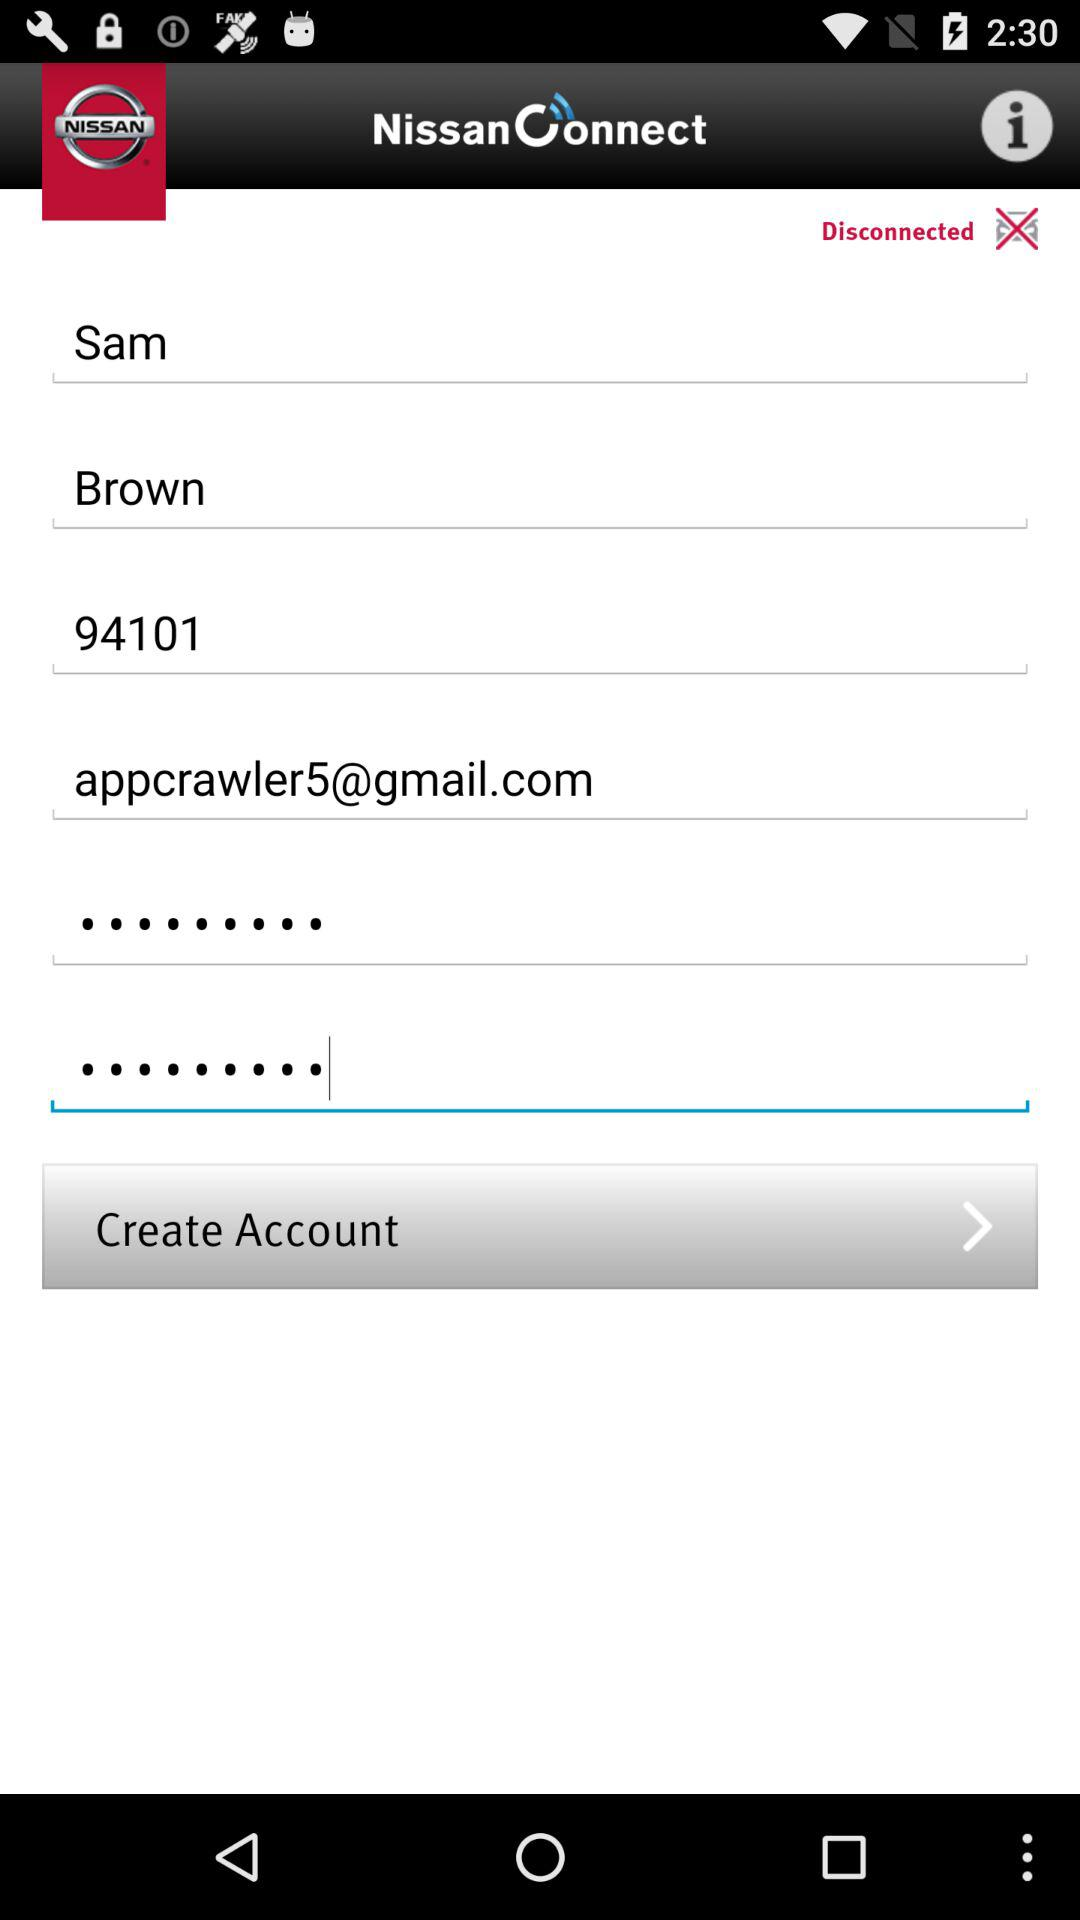What is the email address? The email address is appcrawler5@gmail.com. 